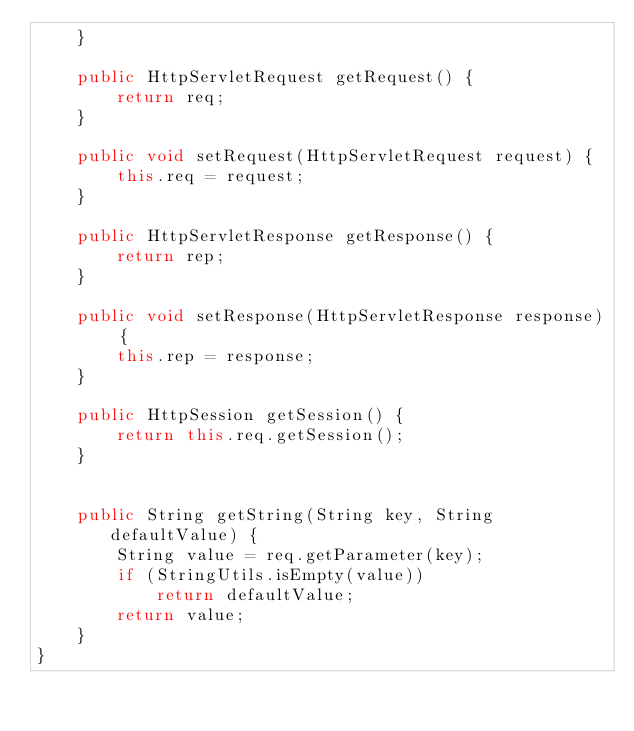<code> <loc_0><loc_0><loc_500><loc_500><_Java_>    }

    public HttpServletRequest getRequest() {
        return req;
    }

    public void setRequest(HttpServletRequest request) {
        this.req = request;
    }

    public HttpServletResponse getResponse() {
        return rep;
    }

    public void setResponse(HttpServletResponse response) {
        this.rep = response;
    }

    public HttpSession getSession() {
        return this.req.getSession();
    }


    public String getString(String key, String defaultValue) {
        String value = req.getParameter(key);
        if (StringUtils.isEmpty(value))
            return defaultValue;
        return value;
    }
}
</code> 